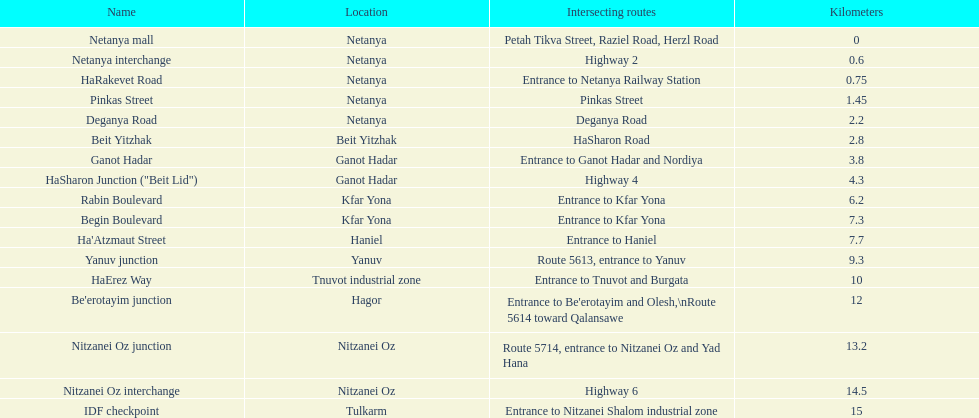Which section is longest?? IDF checkpoint. 